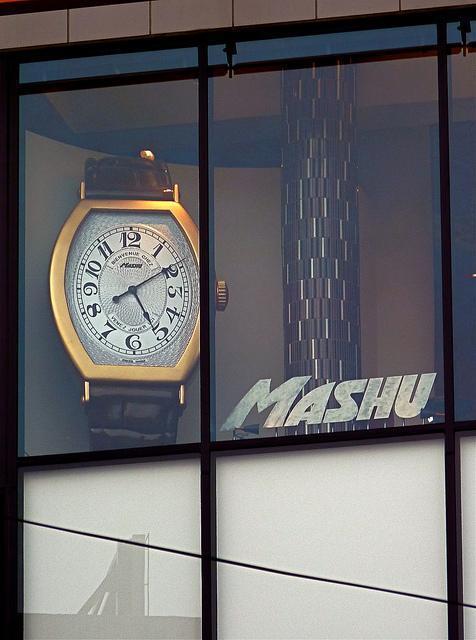How many of the motorcycles are blue?
Give a very brief answer. 0. 